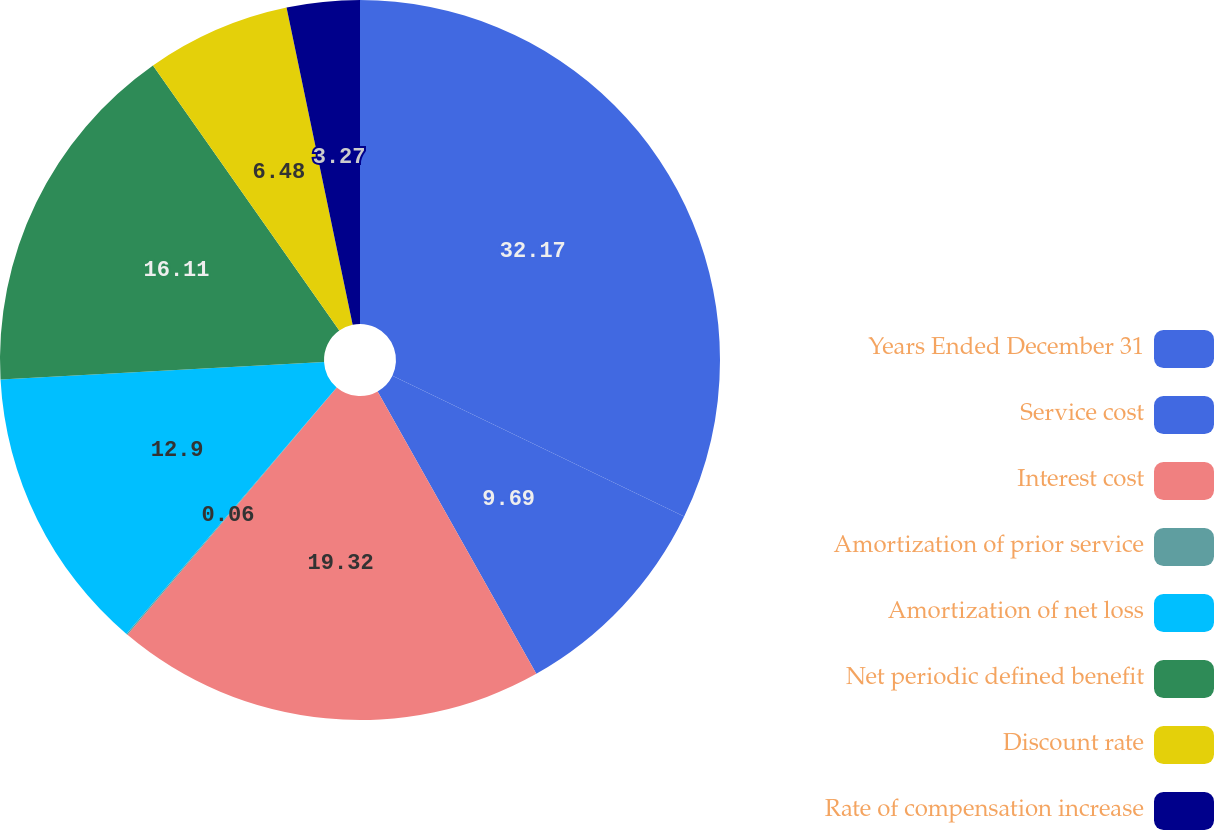Convert chart to OTSL. <chart><loc_0><loc_0><loc_500><loc_500><pie_chart><fcel>Years Ended December 31<fcel>Service cost<fcel>Interest cost<fcel>Amortization of prior service<fcel>Amortization of net loss<fcel>Net periodic defined benefit<fcel>Discount rate<fcel>Rate of compensation increase<nl><fcel>32.16%<fcel>9.69%<fcel>19.32%<fcel>0.06%<fcel>12.9%<fcel>16.11%<fcel>6.48%<fcel>3.27%<nl></chart> 